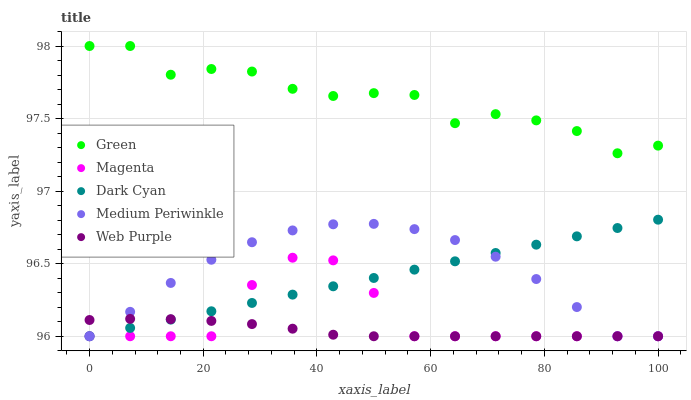Does Web Purple have the minimum area under the curve?
Answer yes or no. Yes. Does Green have the maximum area under the curve?
Answer yes or no. Yes. Does Medium Periwinkle have the minimum area under the curve?
Answer yes or no. No. Does Medium Periwinkle have the maximum area under the curve?
Answer yes or no. No. Is Dark Cyan the smoothest?
Answer yes or no. Yes. Is Green the roughest?
Answer yes or no. Yes. Is Medium Periwinkle the smoothest?
Answer yes or no. No. Is Medium Periwinkle the roughest?
Answer yes or no. No. Does Dark Cyan have the lowest value?
Answer yes or no. Yes. Does Green have the lowest value?
Answer yes or no. No. Does Green have the highest value?
Answer yes or no. Yes. Does Medium Periwinkle have the highest value?
Answer yes or no. No. Is Magenta less than Green?
Answer yes or no. Yes. Is Green greater than Magenta?
Answer yes or no. Yes. Does Magenta intersect Dark Cyan?
Answer yes or no. Yes. Is Magenta less than Dark Cyan?
Answer yes or no. No. Is Magenta greater than Dark Cyan?
Answer yes or no. No. Does Magenta intersect Green?
Answer yes or no. No. 